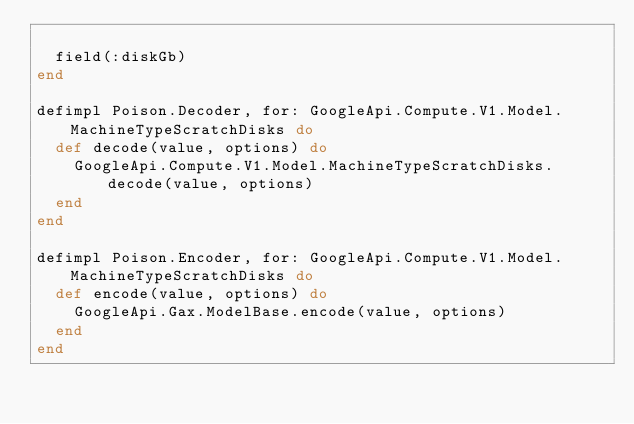Convert code to text. <code><loc_0><loc_0><loc_500><loc_500><_Elixir_>
  field(:diskGb)
end

defimpl Poison.Decoder, for: GoogleApi.Compute.V1.Model.MachineTypeScratchDisks do
  def decode(value, options) do
    GoogleApi.Compute.V1.Model.MachineTypeScratchDisks.decode(value, options)
  end
end

defimpl Poison.Encoder, for: GoogleApi.Compute.V1.Model.MachineTypeScratchDisks do
  def encode(value, options) do
    GoogleApi.Gax.ModelBase.encode(value, options)
  end
end
</code> 